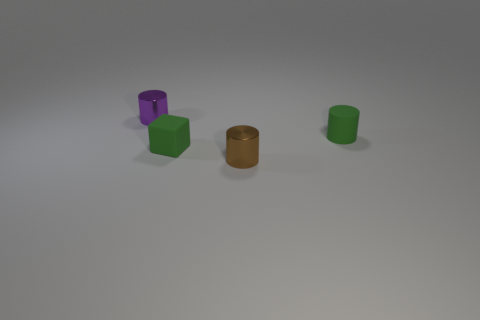What color is the small object that is in front of the small green cylinder and to the right of the rubber block?
Your answer should be very brief. Brown. How many things are either tiny shiny cylinders that are in front of the purple thing or big yellow spheres?
Your answer should be very brief. 1. What material is the green cube?
Offer a terse response. Rubber. Is the purple metallic cylinder the same size as the brown thing?
Give a very brief answer. Yes. How many cylinders are purple metallic objects or small rubber things?
Offer a very short reply. 2. There is a tiny shiny object in front of the tiny green rubber object that is on the left side of the brown cylinder; what color is it?
Make the answer very short. Brown. Is the number of tiny things that are on the right side of the tiny brown metallic object less than the number of tiny objects that are in front of the tiny green rubber cylinder?
Offer a very short reply. Yes. There is a purple metal cylinder; is its size the same as the shiny object that is right of the purple cylinder?
Your answer should be very brief. Yes. What is the shape of the thing that is behind the tiny matte block and in front of the small purple cylinder?
Your answer should be very brief. Cylinder. What size is the cylinder that is made of the same material as the green cube?
Your response must be concise. Small. 